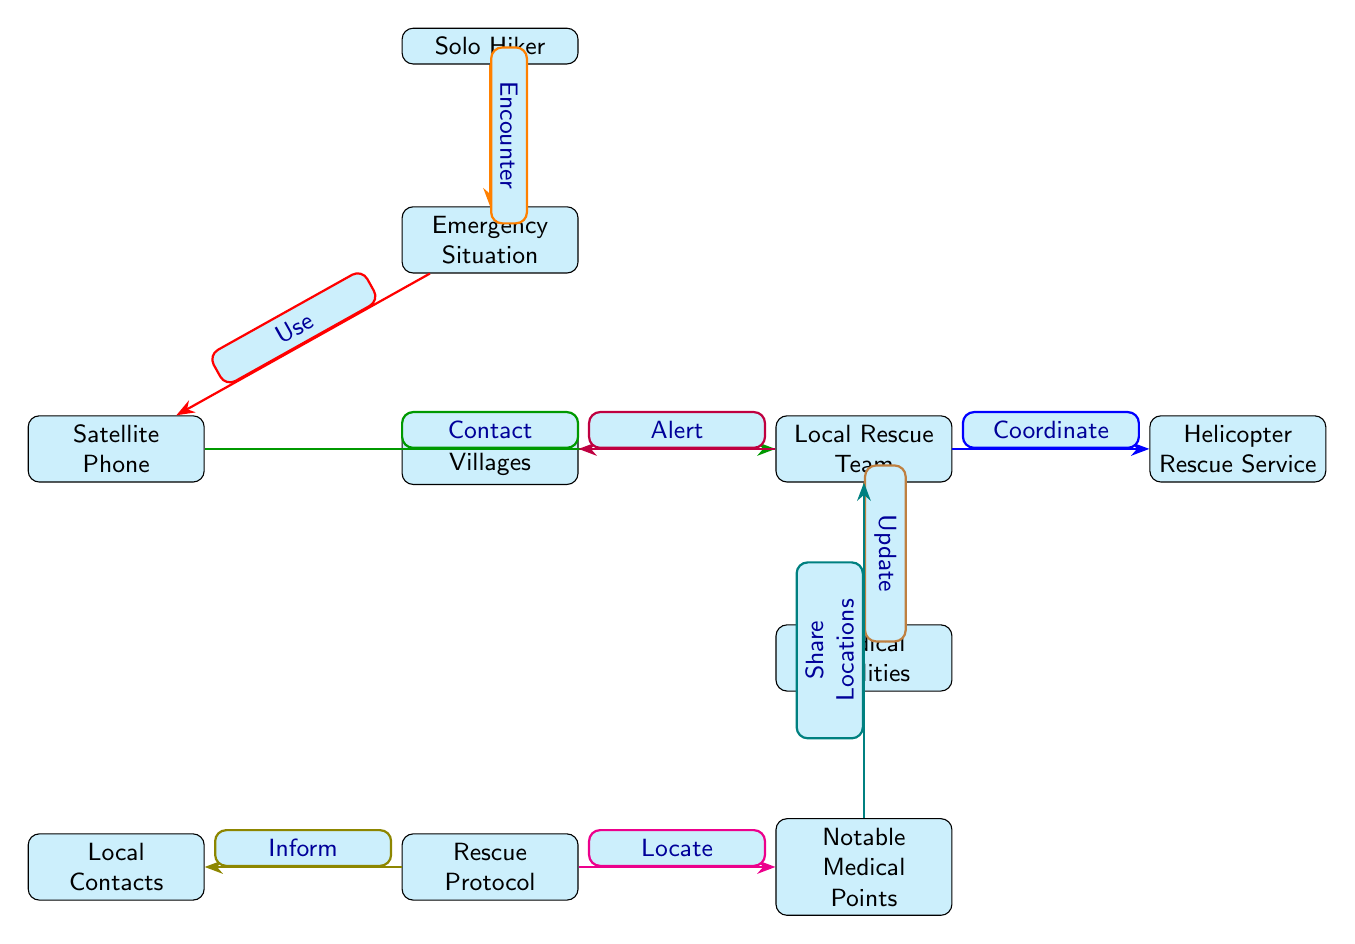What represents the starting point in the diagram? The starting point in the diagram is represented by the node labeled "Solo Hiker." It shows the initial status of an individual who may encounter an emergency.
Answer: Solo Hiker How many main nodes are connected to the 'Emergency Situation'? The 'Emergency Situation' node is connected to three main nodes: 'Satellite Phone,' 'Local Rescue Team,' and 'Nearest Villages.' Therefore, counting each node provides a total of three nodes connected to it.
Answer: 3 What action is suggested after encountering an emergency situation? The action suggested after encountering an emergency situation is to "Use" the 'Satellite Phone.' This step indicates the initial course of action in the emergency protocol.
Answer: Use Which node coordinates with the 'Helicopter Rescue Service'? The 'Local Rescue Team' node is responsible for coordinating with the 'Helicopter Rescue Service.' The diagram indicates this connection through a thick blue edge labeled "Coordinate."
Answer: Local Rescue Team What should be done by the 'Rescue Protocol' before contacting local medical facilities? Before contacting local medical facilities, the 'Rescue Protocol' should "Inform" the 'Local Contacts.' This step is crucial for proper communication and coordination before reaching medical support.
Answer: Inform Which two elements share a connection through the action "Share Locations"? The action "Share Locations" connects the 'Notable Medical Points' and the 'Local Rescue Team.' This indicates that notable medical points are vital for informing the rescue team about medical facilities nearby.
Answer: Notable Medical Points, Local Rescue Team What is the role of the 'Local Contacts' in the emergency response protocol? The role of the 'Local Contacts' is to be informed by the 'Rescue Protocol,' indicating that they are likely there to provide valuable information to assist with the emergency response efforts.
Answer: Inform How is the 'Local Rescue Team' updated regarding the situation? The 'Local Rescue Team' is updated regarding the situation by the action "Update," which comes from the 'Local Rescue Team.' This indicates the recursive nature of communication within this protocol.
Answer: Update Which node is contacted after using the 'Satellite Phone'? After using the 'Satellite Phone', the node that is contacted is the 'Local Rescue Team.' This reflects the sequential action taken in the protocol following the emergency situation.
Answer: Local Rescue Team 